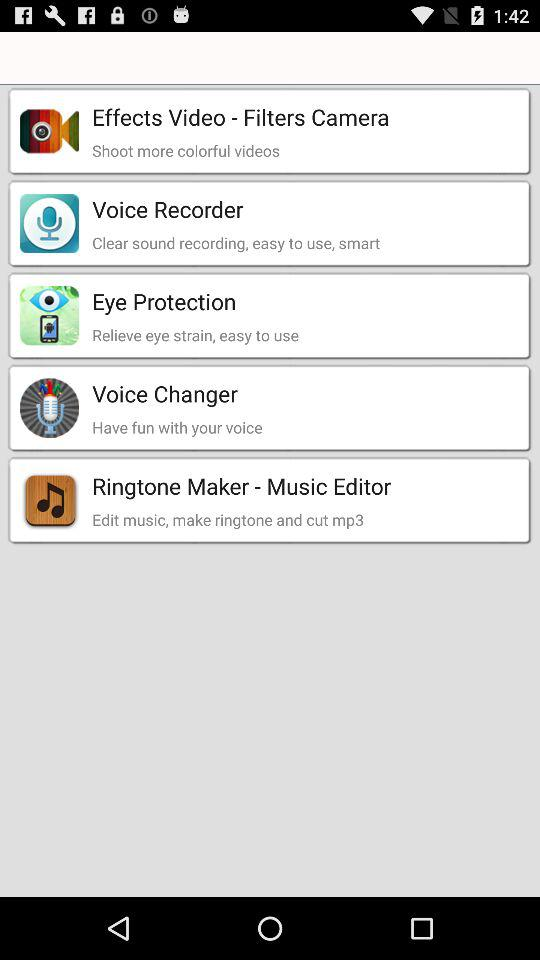Which application can we use to shoot more colorful videos? You can use the "Effects Video - Filters Camera" application to shoot more colorful videos. 